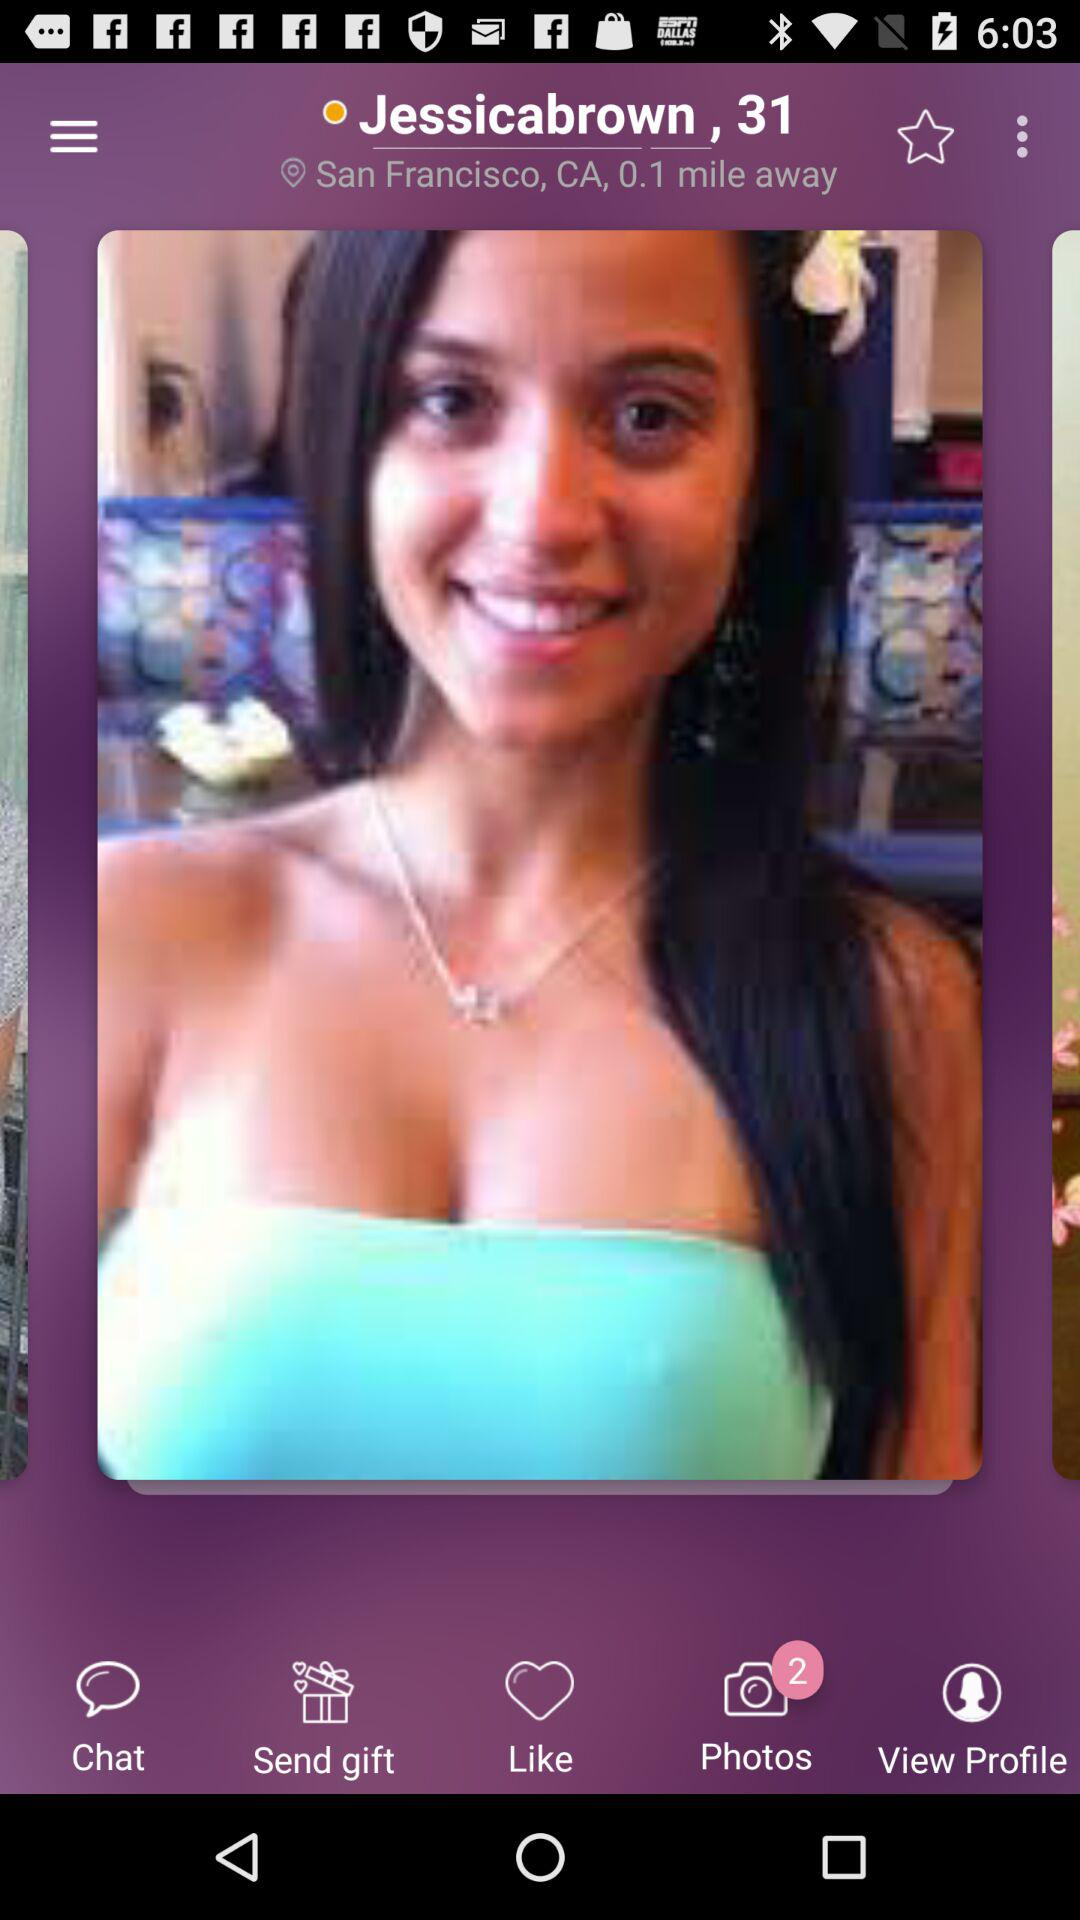What is the location? The location is San Francisco, CA. 